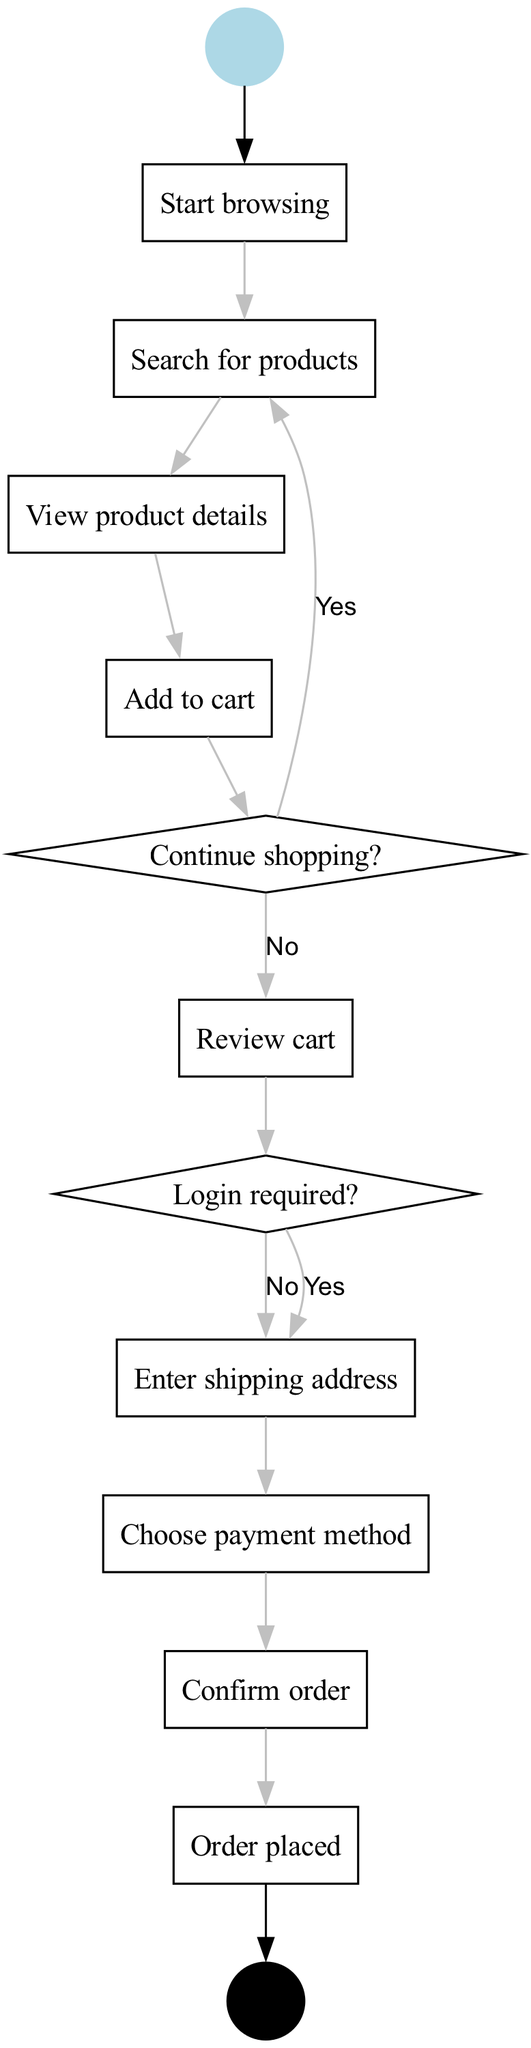What is the initial activity in the online shopping process? The initial activity is indicated as the first rectangular node following the start node, which is "Search for products."
Answer: Search for products How many decision nodes are present in the diagram? The diagram includes two decision nodes, which are represented as diamond shapes, specifically "Continue shopping?" and "Login required?"
Answer: 2 What happens if the user chooses "Yes" at the first decision node? If the user selects "Yes" at the "Continue shopping?" decision node, the flow loops back to the "Search for products" activity, allowing them to continue browsing for more items.
Answer: Search for products What is the final node in the process? The final node, indicated as the last node before the end circle, states "Order placed," representing the completion of the shopping journey.
Answer: Order placed What activity follows "Review cart"? After "Review cart," the user proceeds to the decision node labeled "Login required?" which determines whether they need to log in before entering their shipping address.
Answer: Login required? What is one way a user can get back to exploring products after viewing product details? After "View product details," the user can go back to searching for products by selecting "Continue shopping?" and choosing "Yes," which leads back to the "Search for products" activity.
Answer: Search for products Which activities are grouped before the "Confirm order"? Before reaching the "Confirm order," the grouped activities include entering a shipping address and choosing a payment method, which are sequentially followed before confirmation.
Answer: Enter shipping address, Choose payment method What type of node is "Login required?" "Login required?" is a decision node, which is represented by a diamond shape and presents two options: "Yes" and "No" for the user's choice.
Answer: Decision node What are the three possible actions before "Proceed to checkout"? The three actions leading up to "Proceed to checkout" include "Add to cart," "Review cart," and the decision on "Continue shopping?" based on user interaction.
Answer: Add to cart, Review cart, Continue shopping? 